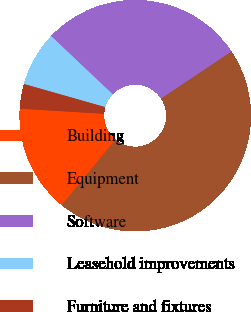Convert chart. <chart><loc_0><loc_0><loc_500><loc_500><pie_chart><fcel>Building<fcel>Equipment<fcel>Software<fcel>Leasehold improvements<fcel>Furniture and fixtures<nl><fcel>15.01%<fcel>45.34%<fcel>28.56%<fcel>7.64%<fcel>3.45%<nl></chart> 